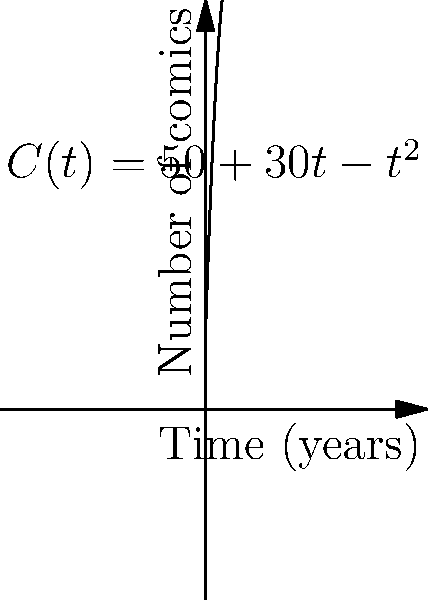A comic collector's collection size over time is modeled by the function $C(t) = 50 + 30t - t^2$, where $C(t)$ represents the number of comics and $t$ is the time in years. At what point in time is the rate of change of the collection size equal to zero? To find when the rate of change is zero, we need to follow these steps:

1) The rate of change is represented by the derivative of the function. Let's find $C'(t)$:
   $C'(t) = \frac{d}{dt}(50 + 30t - t^2) = 30 - 2t$

2) We want to find when this rate of change equals zero:
   $C'(t) = 0$
   $30 - 2t = 0$

3) Solve this equation for $t$:
   $-2t = -30$
   $t = 15$

4) Therefore, the rate of change of the collection size is zero when $t = 15$ years.

5) We can verify this is a maximum point by checking the second derivative:
   $C''(t) = -2$, which is negative, confirming a maximum.
Answer: 15 years 